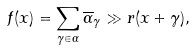<formula> <loc_0><loc_0><loc_500><loc_500>f ( x ) = \sum _ { \gamma \in \Gamma } { \overline { \alpha } } _ { \gamma } \gg r ( x + \gamma ) ,</formula> 